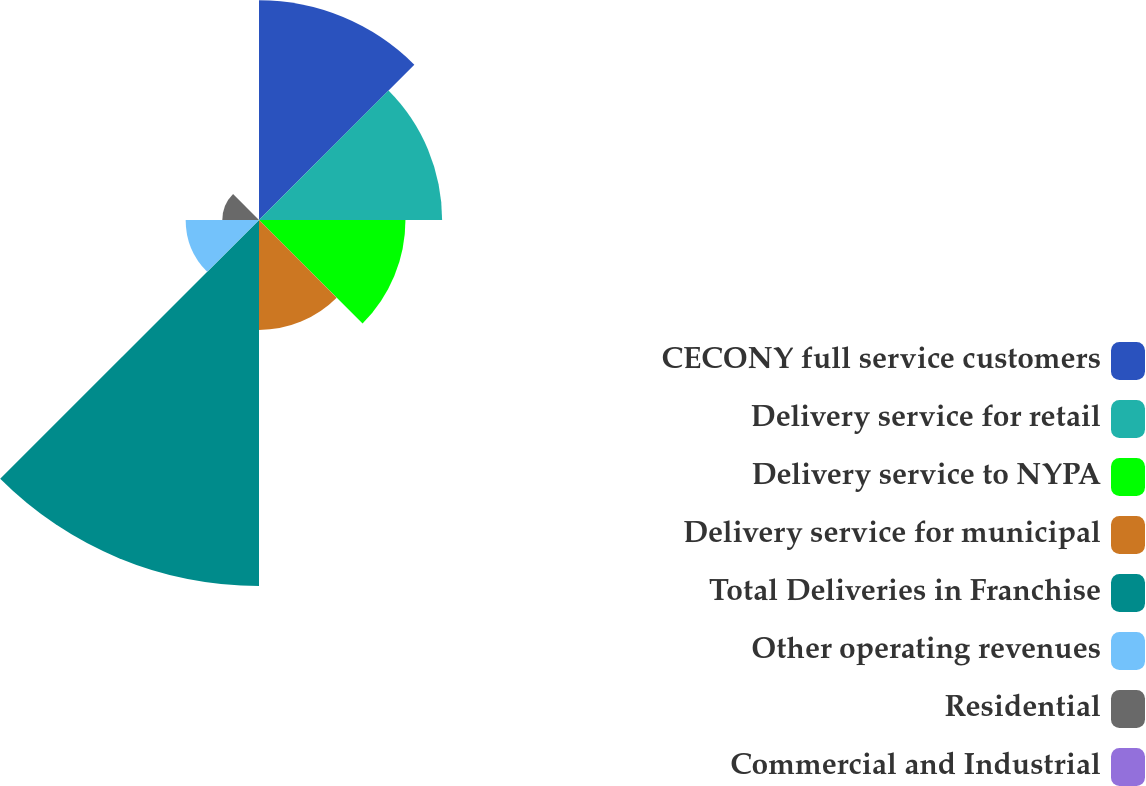Convert chart. <chart><loc_0><loc_0><loc_500><loc_500><pie_chart><fcel>CECONY full service customers<fcel>Delivery service for retail<fcel>Delivery service to NYPA<fcel>Delivery service for municipal<fcel>Total Deliveries in Franchise<fcel>Other operating revenues<fcel>Residential<fcel>Commercial and Industrial<nl><fcel>19.35%<fcel>16.13%<fcel>12.9%<fcel>9.68%<fcel>32.24%<fcel>6.46%<fcel>3.23%<fcel>0.01%<nl></chart> 